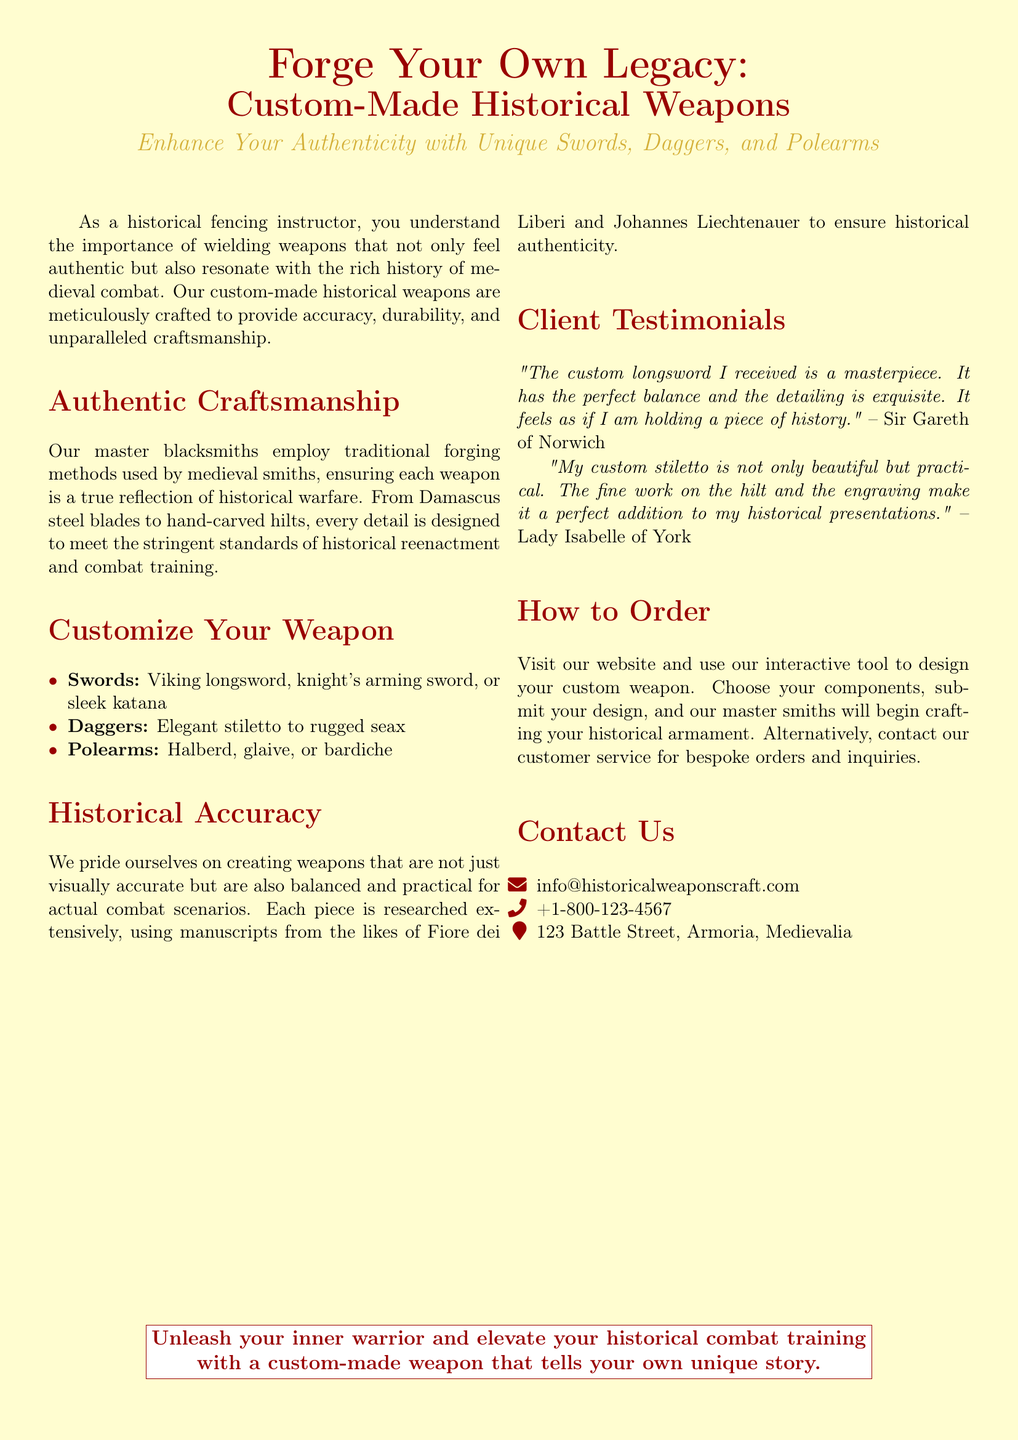What is the primary focus of the advertisement? The advertisement emphasizes the importance of wielding authentic weapons for historical fencing and combat training.
Answer: Custom-Made Historical Weapons Who are the craftsmen behind the weapons? The document states that master blacksmiths are responsible for crafting the weapons using traditional methods.
Answer: Master blacksmiths What types of custom weapons can you order? The advertisement lists various types of weapons available for customization including swords, daggers, and polearms.
Answer: Swords, daggers, and polearms What is one of the testimonials mentioned? A testimonial highlights the excellent craftsmanship and balance of a custom longsword received by a client.
Answer: "The custom longsword I received is a masterpiece." How can you design your custom weapon? The document specifies that customers can use an interactive tool on the website to design their weapon.
Answer: Interactive tool What is one method of contacting the company? The document provides an email address for customer inquiries as a method of contact.
Answer: info@historicalweaponscraft.com Who is the author of the historical manuscripts referenced? The advertisement mentions two historical figures known for their manuscripts on combat techniques.
Answer: Fiore dei Liberi and Johannes Liechtenauer What is the location of the company's address? The advertisement specifies the street and city for the company's location in the contact section.
Answer: 123 Battle Street, Armoria, Medievalia What is a key feature of the weapons described? The advertisement emphasizes that the weapons are balanced and practical for combat scenarios.
Answer: Balanced and practical 